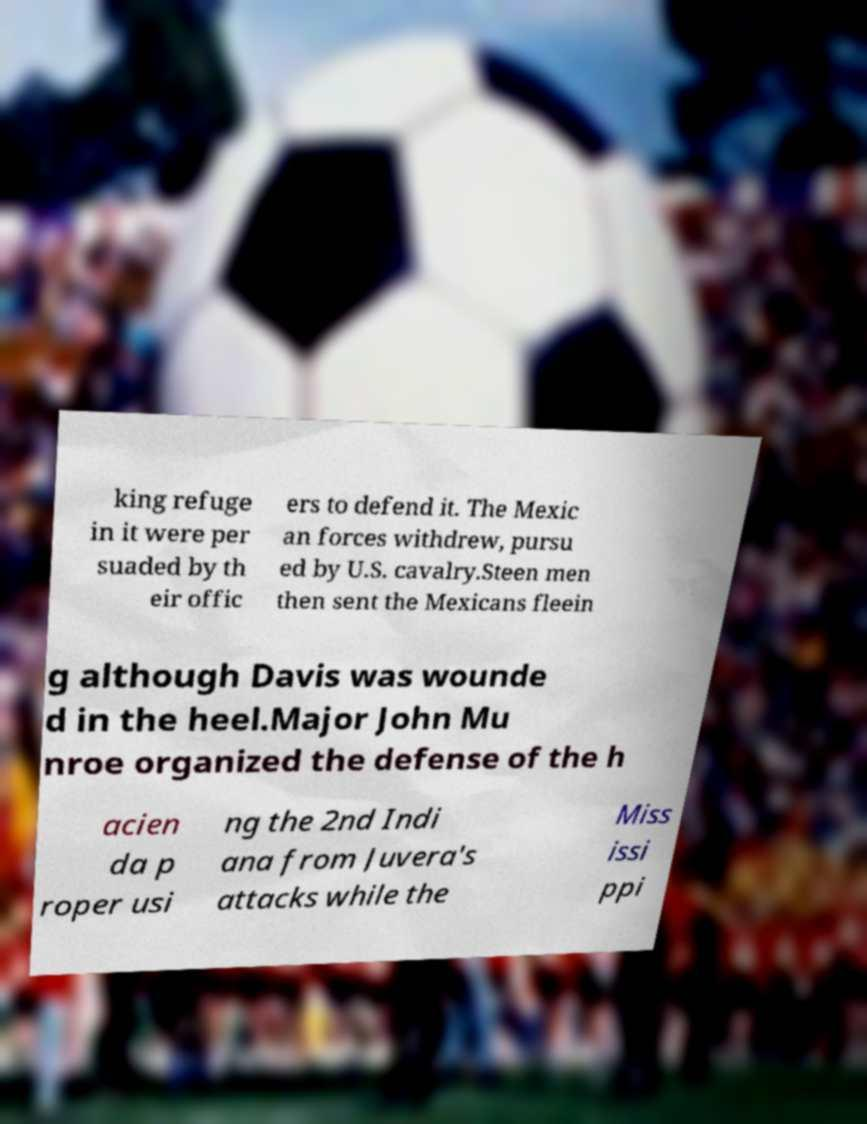Can you accurately transcribe the text from the provided image for me? king refuge in it were per suaded by th eir offic ers to defend it. The Mexic an forces withdrew, pursu ed by U.S. cavalry.Steen men then sent the Mexicans fleein g although Davis was wounde d in the heel.Major John Mu nroe organized the defense of the h acien da p roper usi ng the 2nd Indi ana from Juvera's attacks while the Miss issi ppi 